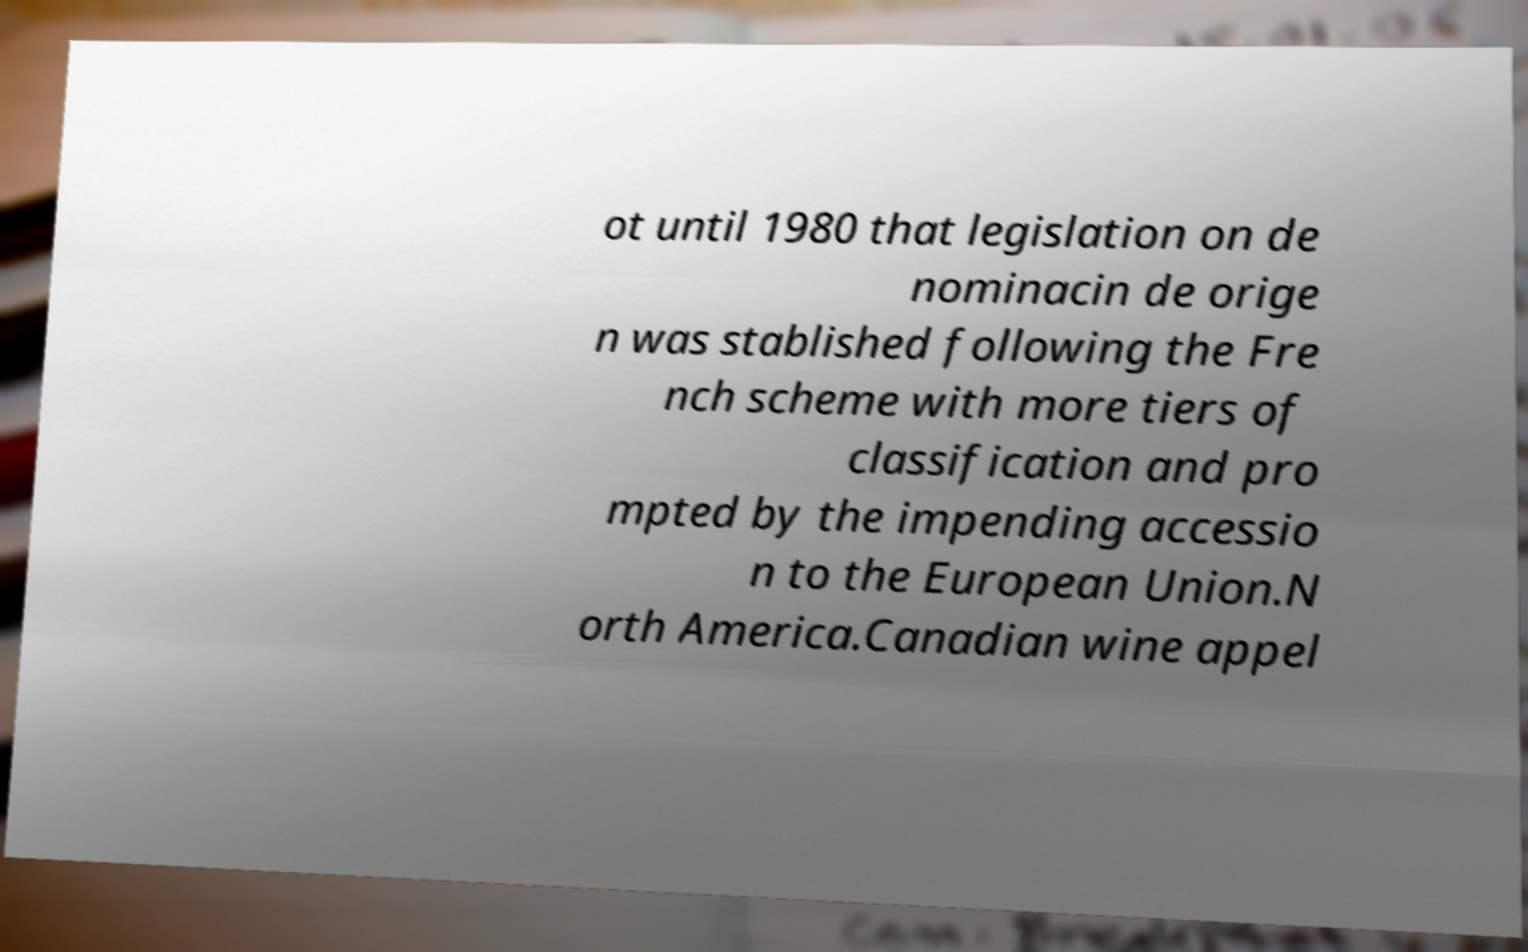Can you read and provide the text displayed in the image?This photo seems to have some interesting text. Can you extract and type it out for me? ot until 1980 that legislation on de nominacin de orige n was stablished following the Fre nch scheme with more tiers of classification and pro mpted by the impending accessio n to the European Union.N orth America.Canadian wine appel 